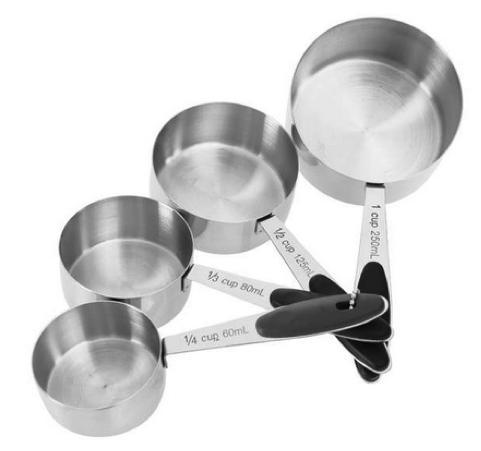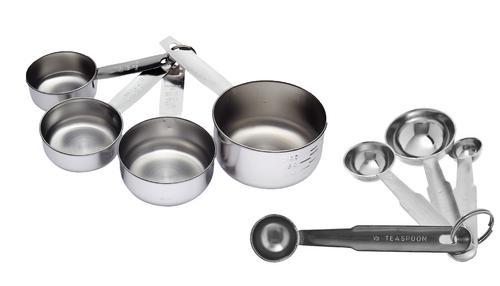The first image is the image on the left, the second image is the image on the right. For the images displayed, is the sentence "An image features only a joined group of exactly four measuring cups." factually correct? Answer yes or no. Yes. 